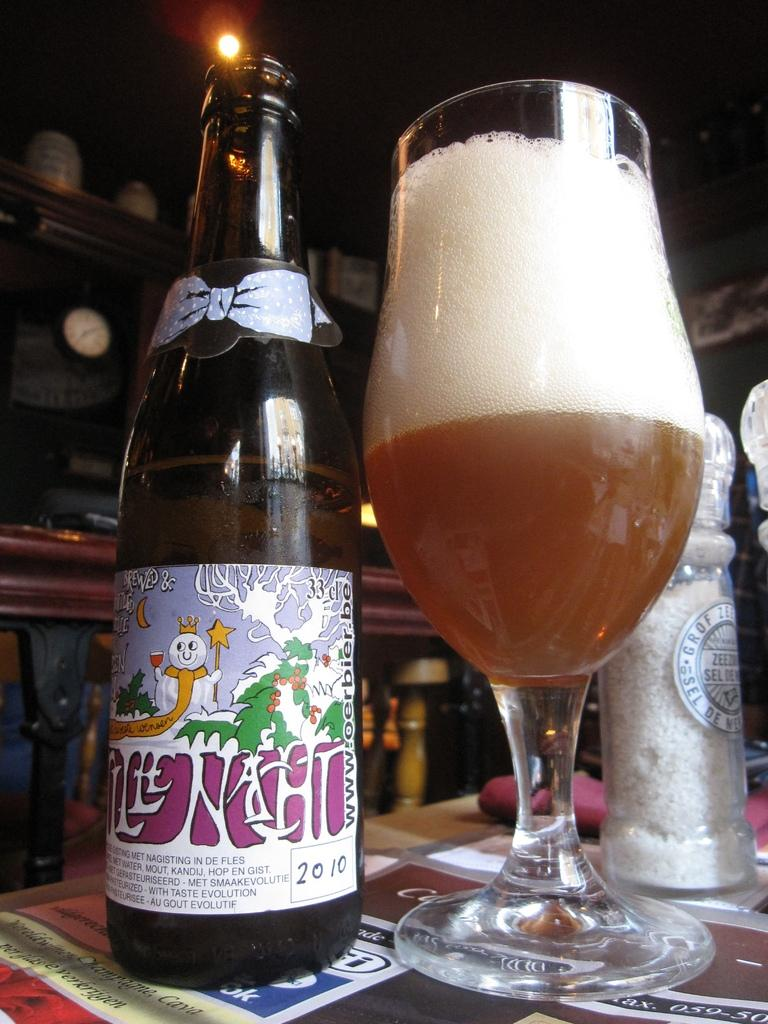<image>
Describe the image concisely. A bottle of beer and cup that was bottled in 2010 